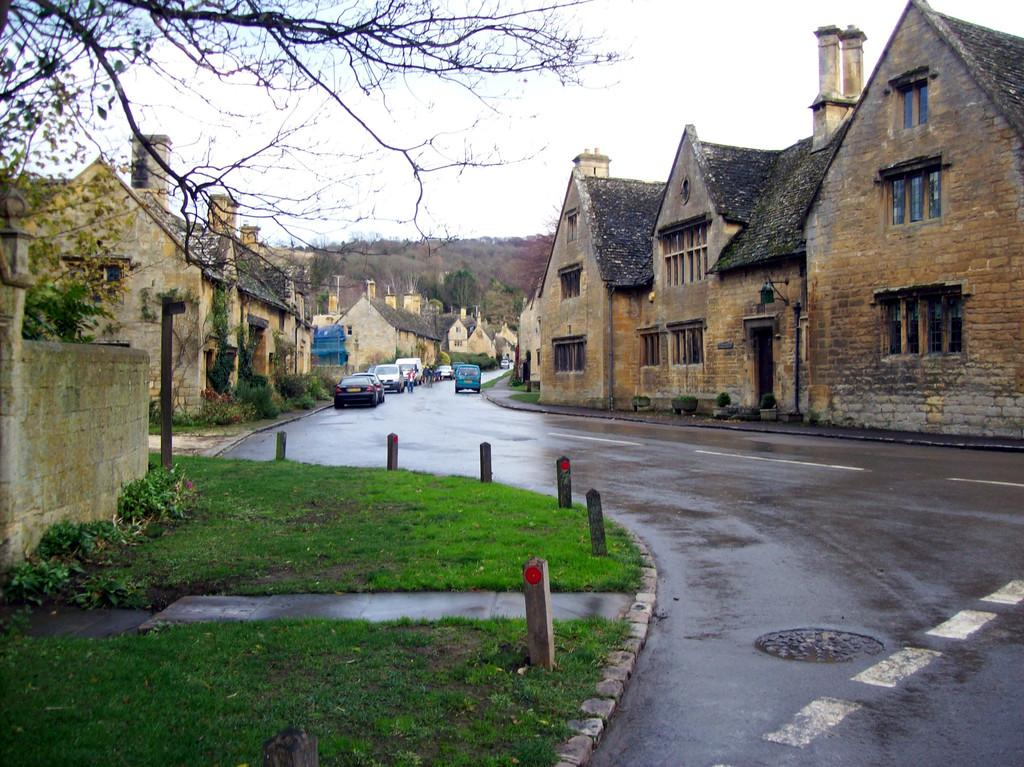What type of structures can be seen in the image? There are buildings in the image. What is happening on the road in the image? Vehicles are present on the road in the image. What type of vegetation is visible in the image? Grass and plants are present in the image. What are the poles used for in the image? The poles are present in the image, but their specific purpose is not clear from the facts provided. What other objects can be seen on the ground in the image? There are other objects on the ground in the image, but their specific nature is not clear from the facts provided. What can be seen in the background of the image? The sky is visible in the background of the image. How many legs does the vessel have in the image? There is no vessel present in the image, so it is not possible to determine the number of legs it might have. 